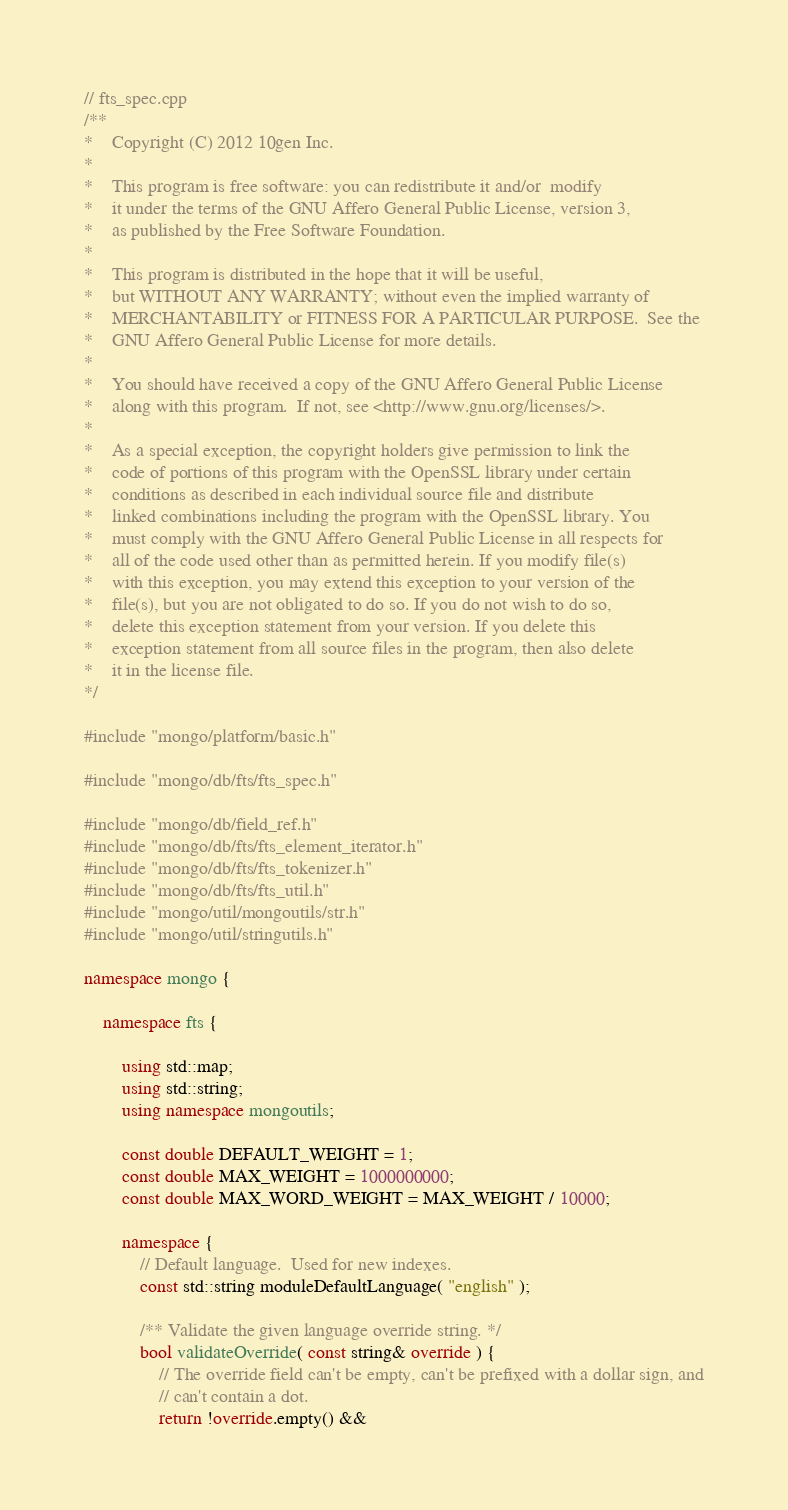<code> <loc_0><loc_0><loc_500><loc_500><_C++_>// fts_spec.cpp
/**
*    Copyright (C) 2012 10gen Inc.
*
*    This program is free software: you can redistribute it and/or  modify
*    it under the terms of the GNU Affero General Public License, version 3,
*    as published by the Free Software Foundation.
*
*    This program is distributed in the hope that it will be useful,
*    but WITHOUT ANY WARRANTY; without even the implied warranty of
*    MERCHANTABILITY or FITNESS FOR A PARTICULAR PURPOSE.  See the
*    GNU Affero General Public License for more details.
*
*    You should have received a copy of the GNU Affero General Public License
*    along with this program.  If not, see <http://www.gnu.org/licenses/>.
*
*    As a special exception, the copyright holders give permission to link the
*    code of portions of this program with the OpenSSL library under certain
*    conditions as described in each individual source file and distribute
*    linked combinations including the program with the OpenSSL library. You
*    must comply with the GNU Affero General Public License in all respects for
*    all of the code used other than as permitted herein. If you modify file(s)
*    with this exception, you may extend this exception to your version of the
*    file(s), but you are not obligated to do so. If you do not wish to do so,
*    delete this exception statement from your version. If you delete this
*    exception statement from all source files in the program, then also delete
*    it in the license file.
*/

#include "mongo/platform/basic.h"

#include "mongo/db/fts/fts_spec.h"

#include "mongo/db/field_ref.h"
#include "mongo/db/fts/fts_element_iterator.h"
#include "mongo/db/fts/fts_tokenizer.h"
#include "mongo/db/fts/fts_util.h"
#include "mongo/util/mongoutils/str.h"
#include "mongo/util/stringutils.h"

namespace mongo {

    namespace fts {

        using std::map;
        using std::string;
        using namespace mongoutils;

        const double DEFAULT_WEIGHT = 1;
        const double MAX_WEIGHT = 1000000000;
        const double MAX_WORD_WEIGHT = MAX_WEIGHT / 10000;

        namespace {
            // Default language.  Used for new indexes.
            const std::string moduleDefaultLanguage( "english" );

            /** Validate the given language override string. */
            bool validateOverride( const string& override ) {
                // The override field can't be empty, can't be prefixed with a dollar sign, and
                // can't contain a dot.
                return !override.empty() &&</code> 